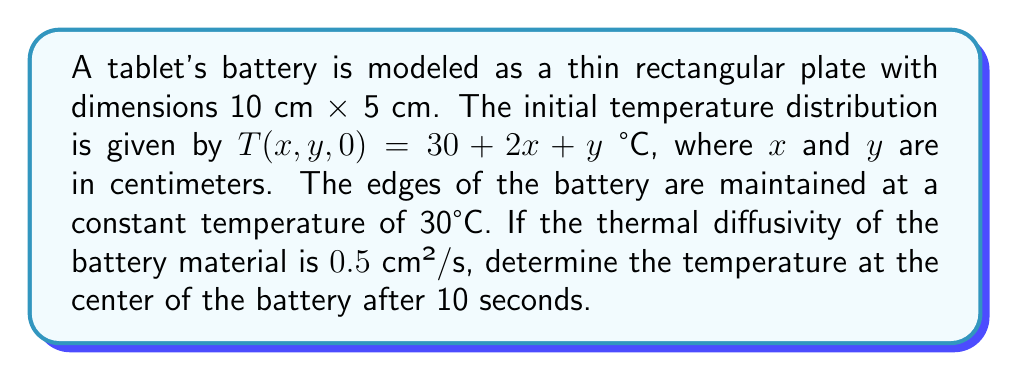Help me with this question. To solve this problem, we'll use the 2D heat equation and separation of variables method:

1) The 2D heat equation is:
   $$\frac{\partial T}{\partial t} = \alpha \left(\frac{\partial^2 T}{\partial x^2} + \frac{\partial^2 T}{\partial y^2}\right)$$

2) The boundary conditions are:
   $T(0,y,t) = T(10,y,t) = T(x,0,t) = T(x,5,t) = 30$ °C

3) We can separate the solution into steady-state and transient parts:
   $T(x,y,t) = S(x,y) + V(x,y,t)$

4) The steady-state solution $S(x,y) = 30$ satisfies the boundary conditions.

5) For the transient part, we use separation of variables:
   $V(x,y,t) = X(x)Y(y)e^{-\lambda\alpha t}$

6) Solving the resulting ODEs, we get:
   $X(x) = A_n \sin(\frac{n\pi x}{10})$, $Y(y) = B_m \sin(\frac{m\pi y}{5})$

7) The general solution is:
   $$T(x,y,t) = 30 + \sum_{n=1}^{\infty}\sum_{m=1}^{\infty} C_{nm} \sin(\frac{n\pi x}{10})\sin(\frac{m\pi y}{5})e^{-\alpha(\frac{n^2\pi^2}{100}+\frac{m^2\pi^2}{25})t}$$

8) Using the initial condition, we can find $C_{nm}$:
   $$C_{nm} = \frac{4}{50}\int_0^{10}\int_0^5 (2x+y)\sin(\frac{n\pi x}{10})\sin(\frac{m\pi y}{5})dydx$$

9) After integration, we get:
   $$C_{nm} = \frac{400(1-(-1)^n)}{n^3\pi^3} + \frac{100(1-(-1)^m)}{m^3\pi^3}$$

10) At the center (5,2.5) after 10 seconds:
    $$T(5,2.5,10) = 30 + \sum_{n=1,3,5,...}\sum_{m=1,3,5,...} (C_{nm})e^{-0.5(\frac{n^2\pi^2}{100}+\frac{m^2\pi^2}{25})10}$$

11) Calculating the first few terms of the series gives us the approximate solution.
Answer: $T(5,2.5,10) \approx 35.2$ °C 